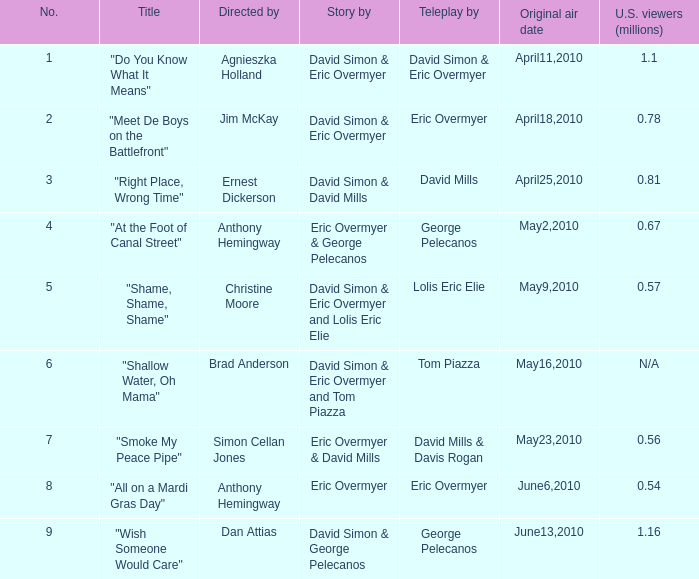What is the greatest amount? 9.0. 